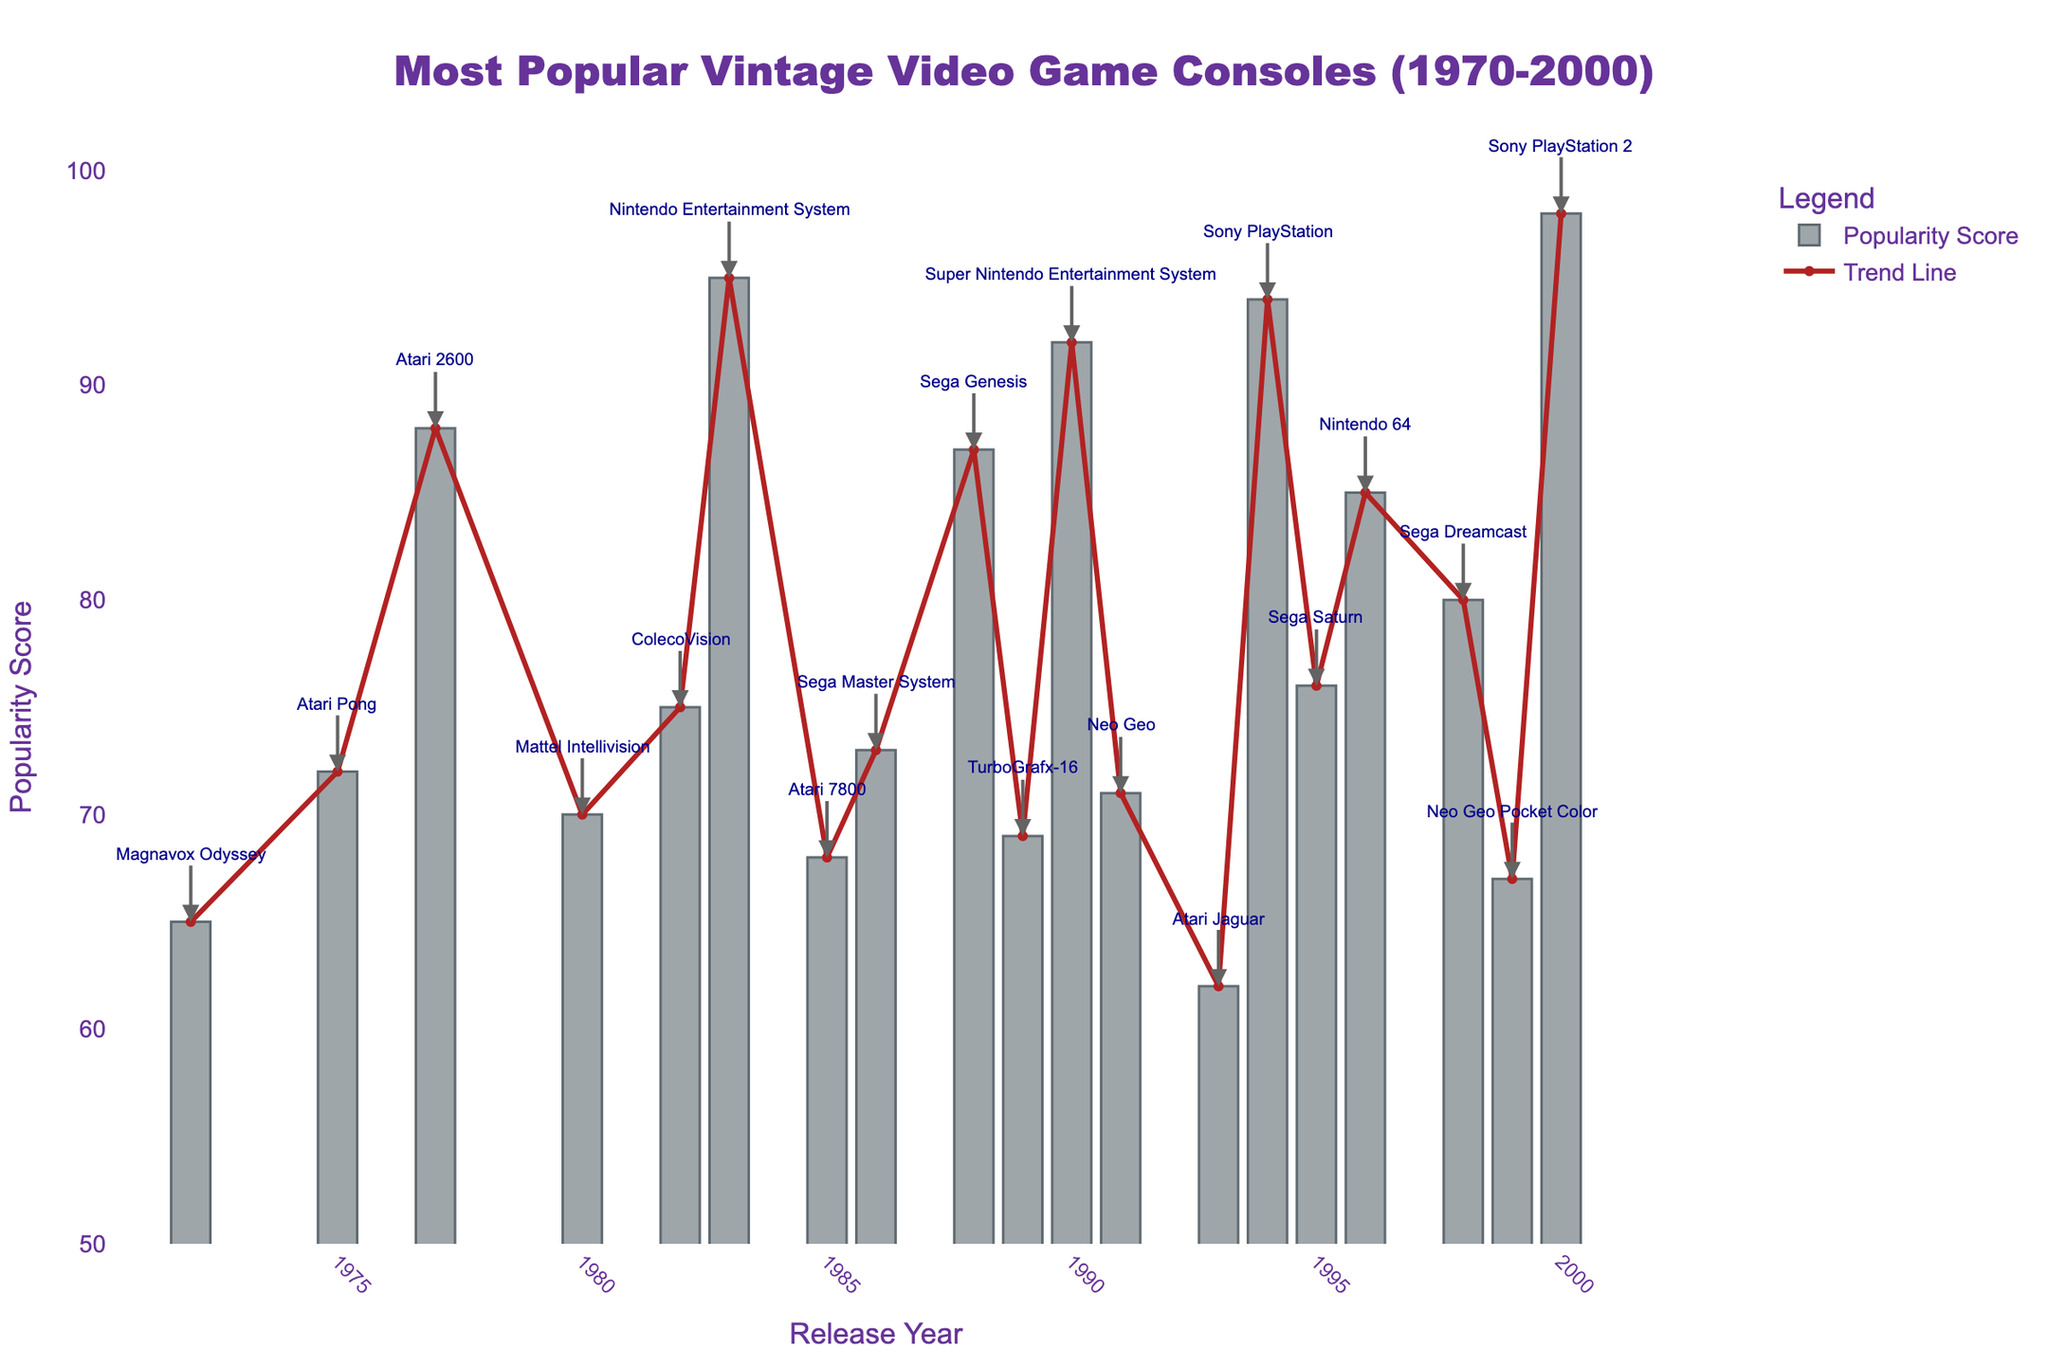Which console has the highest popularity score? The highest bar in the plot represents the console with the highest popularity score. This bar corresponds to the year 2000 and is labeled "Sony PlayStation 2."
Answer: Sony PlayStation 2 What is the popularity score of the Sega Genesis? Locate the year 1988 on the x-axis, and observe the height of the corresponding bar. The annotation indicates the console as "Sega Genesis" with a score of 87.
Answer: 87 How does the popularity of the Atari 2600 compare to the Magnavox Odyssey? The Atari 2600 was released in 1977 and has a popularity score represented by a bar of height 88, while the Magnavox Odyssey was released in 1972 with a score represented by a bar of height 65. 88 is greater than 65.
Answer: Atari 2600 is more popular Which console released in the 1980s has the lowest popularity score? Look at the bars corresponding to the years 1980-1989. The lowest bar is for the year 1989, labeled "TurboGrafx-16," with a popularity score of 69.
Answer: TurboGrafx-16 What is the average popularity score of consoles released after 1995? Consoles released after 1995 include Nintendo 64 (85), Sega Dreamcast (80), Neo Geo Pocket Color (67), and Sony PlayStation 2 (98). The sum is 85 + 80 + 67 + 98 = 330. The number of consoles is 4. The average is 330 / 4 = 82.5.
Answer: 82.5 Which year had the largest increase in popularity score compared to the previous year? Examine the difference in popularity scores between consecutive years. The largest increase is from 1999 (Neo Geo Pocket Color, 67) to 2000 (Sony PlayStation 2, 98), which is an increase of 98 - 67 = 31.
Answer: 2000 Identify the trend in popularity scores from 1983 to 1985. Observe the bars from the years 1983, 1985. The popularity scores are as follows: 1983 (Nintendo Entertainment System, 95), 1985 (Atari 7800, 68). The trend shows a decrease from 95 to 68.
Answer: A decrease Compare the total popularity scores of consoles released before 1985 to those released after 1985. Sum the scores for consoles before 1985: 65 (Magnavox Odyssey) + 72 (Atari Pong) + 88 (Atari 2600) + 70 (Mattel Intellivision) + 75 (ColecoVision) + 95 (Nintendo Entertainment System) = 465. Sum the scores for after 1985: 68 (Atari 7800) + 73 (Sega Master System) + 87 (Sega Genesis) + 69 (TurboGrafx-16) + 92 (Super Nintendo) + 71 (Neo Geo) + 62 (Atari Jaguar) + 94 (Sony PlayStation) + 76 (Sega Saturn) + 85 (Nintendo 64) + 80 (Sega Dreamcast) + 67 (Neo Geo Pocket) + 98 (Sony PlayStation 2) = 1022.
Answer: 465 vs 1022 Which console has a popularity score closest to the median of all scores? List all popularity scores: 65, 72, 88, 70, 75, 95, 68, 73, 87, 69, 92, 71, 62, 94, 76, 85, 80, 67, 98. Arrange them: 62, 65, 67, 68, 69, 70, 71, 72, 73, 75, 76, 80, 85, 87, 88, 92, 94, 95, 98. The median is the middle value, which is 75. The console with a popularity score of 75 is ColecoVision, released in 1982.
Answer: ColecoVision 